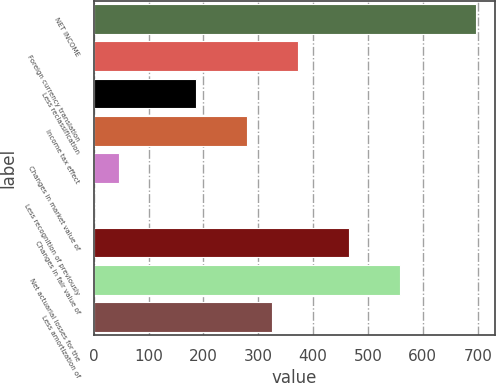Convert chart. <chart><loc_0><loc_0><loc_500><loc_500><bar_chart><fcel>NET INCOME<fcel>Foreign currency translation<fcel>Less reclassification<fcel>Income tax effect<fcel>Changes in market value of<fcel>Less recognition of previously<fcel>Changes in fair value of<fcel>Net actuarial losses for the<fcel>Less amortization of<nl><fcel>696.75<fcel>371.74<fcel>186.02<fcel>278.88<fcel>46.73<fcel>0.3<fcel>464.6<fcel>557.46<fcel>325.31<nl></chart> 